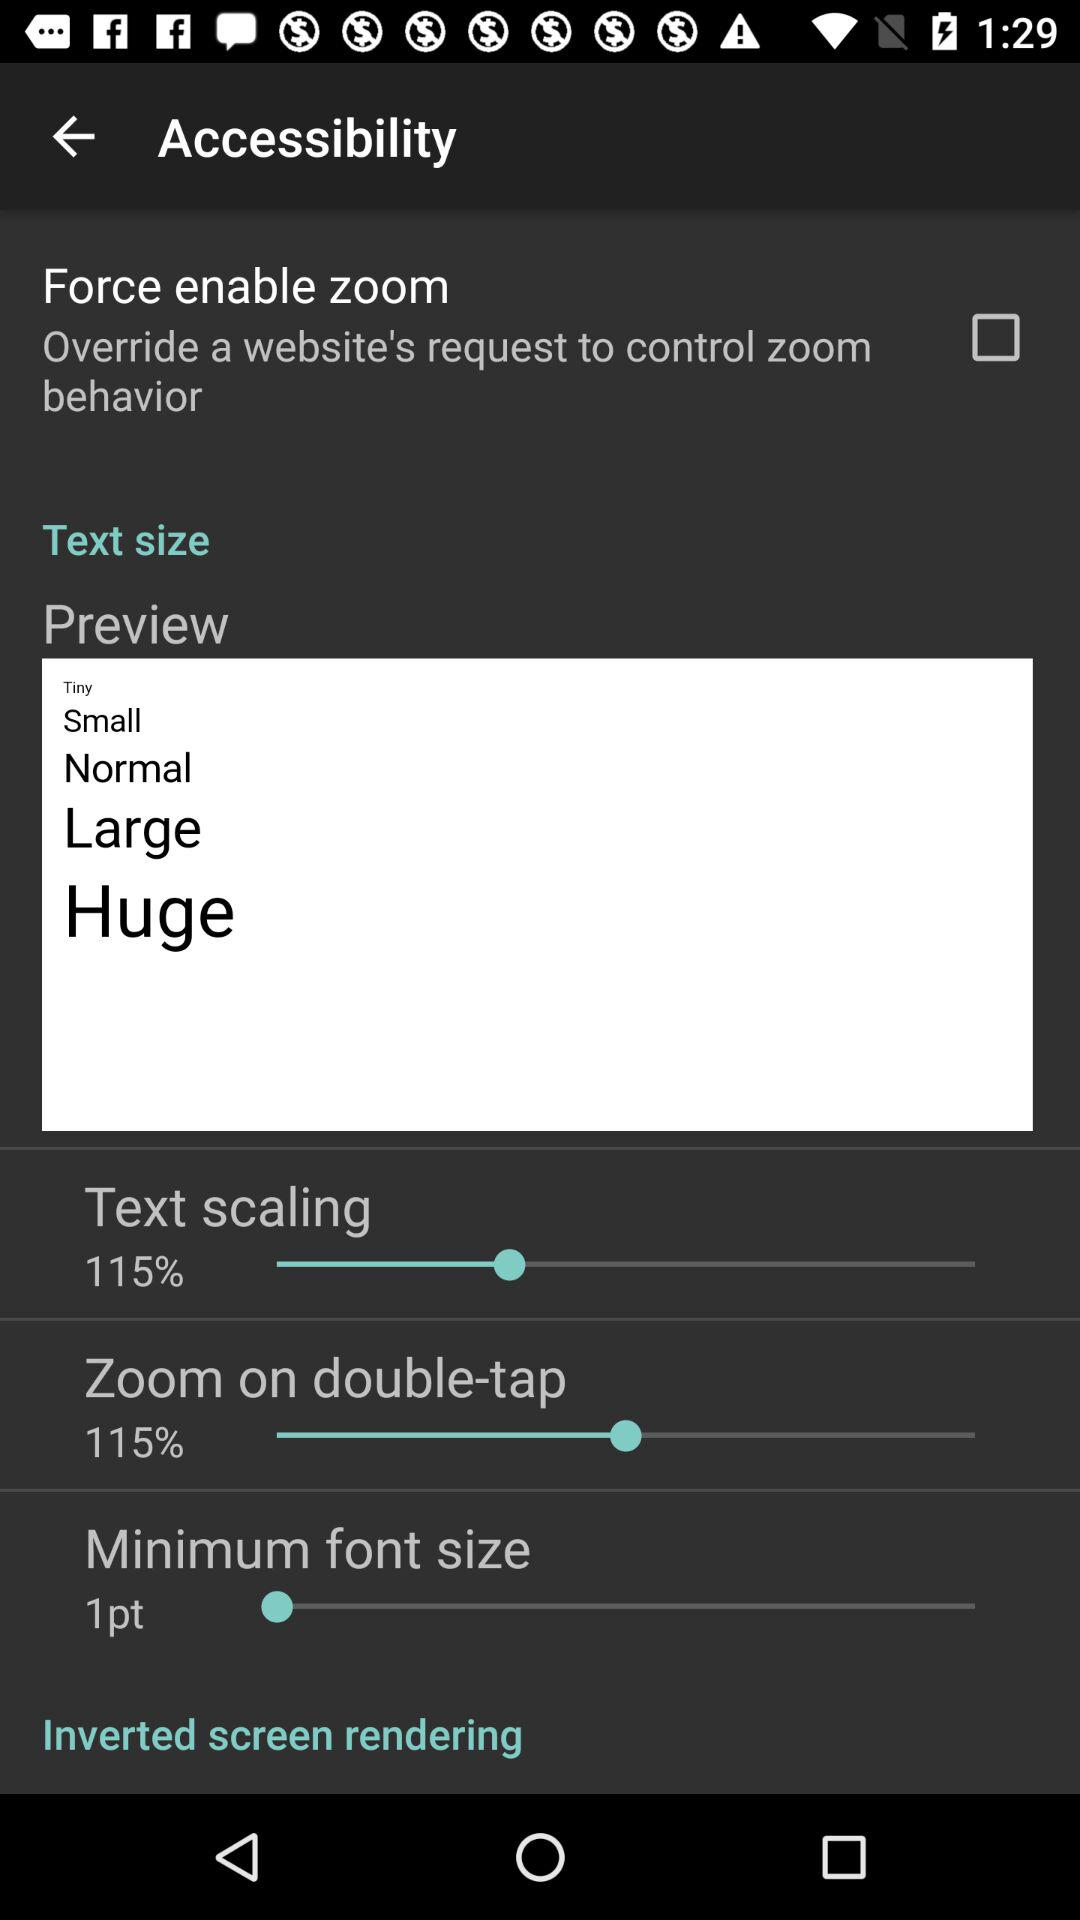What is the percentage of text scaling? The percentage is 115. 